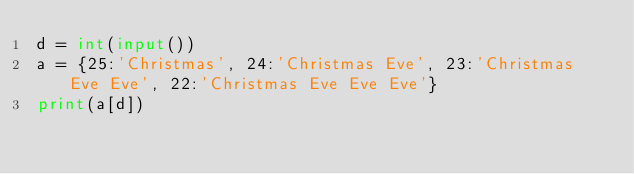Convert code to text. <code><loc_0><loc_0><loc_500><loc_500><_Python_>d = int(input())
a = {25:'Christmas', 24:'Christmas Eve', 23:'Christmas Eve Eve', 22:'Christmas Eve Eve Eve'}
print(a[d])</code> 